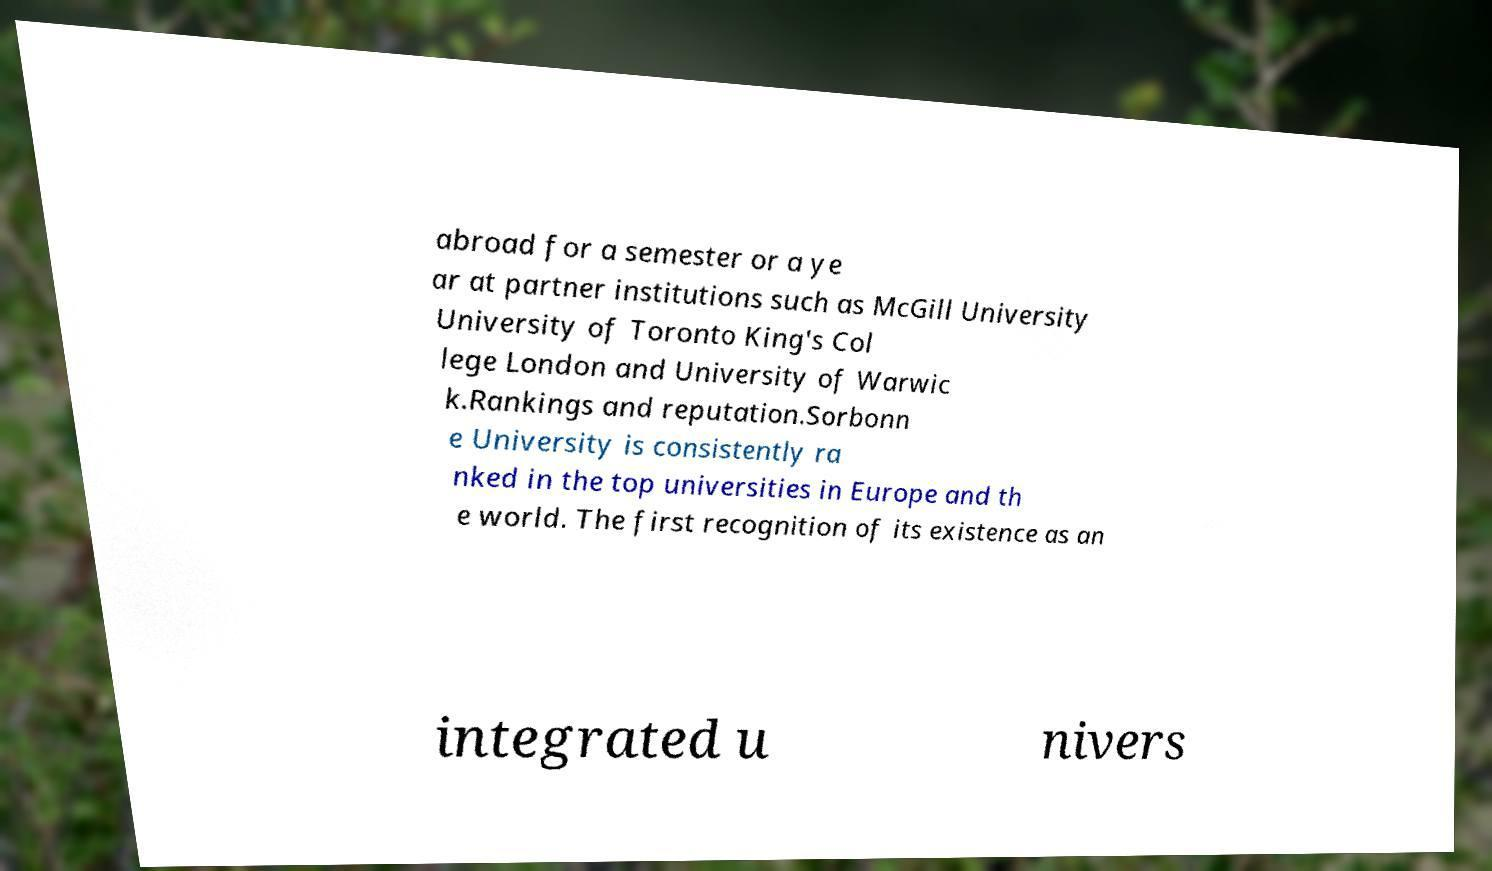Can you accurately transcribe the text from the provided image for me? abroad for a semester or a ye ar at partner institutions such as McGill University University of Toronto King's Col lege London and University of Warwic k.Rankings and reputation.Sorbonn e University is consistently ra nked in the top universities in Europe and th e world. The first recognition of its existence as an integrated u nivers 